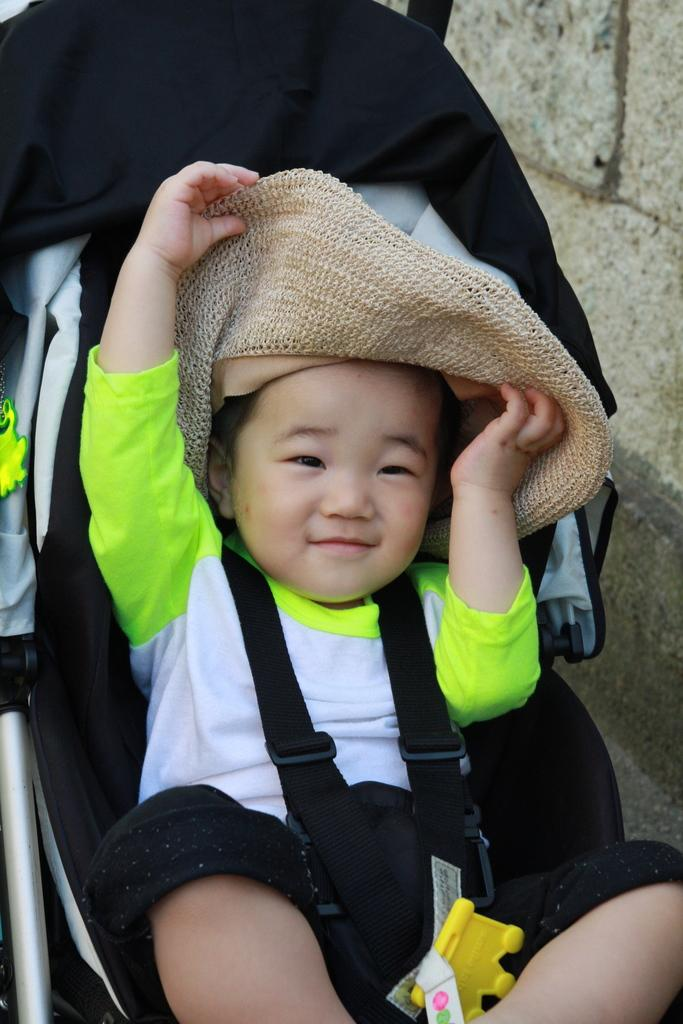What is the main subject of the image? There is a baby in a stroller in the image. Can you describe the setting of the image? There is a wall in the background of the image. How many ants can be seen crawling on the baby's stroller in the image? There are no ants visible in the image; the focus is on the baby in the stroller and the wall in the background. 